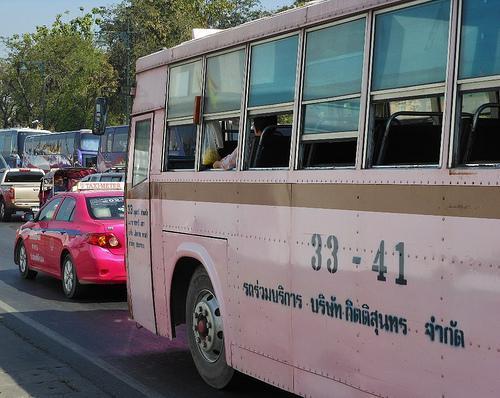How many buses are there?
Give a very brief answer. 1. 